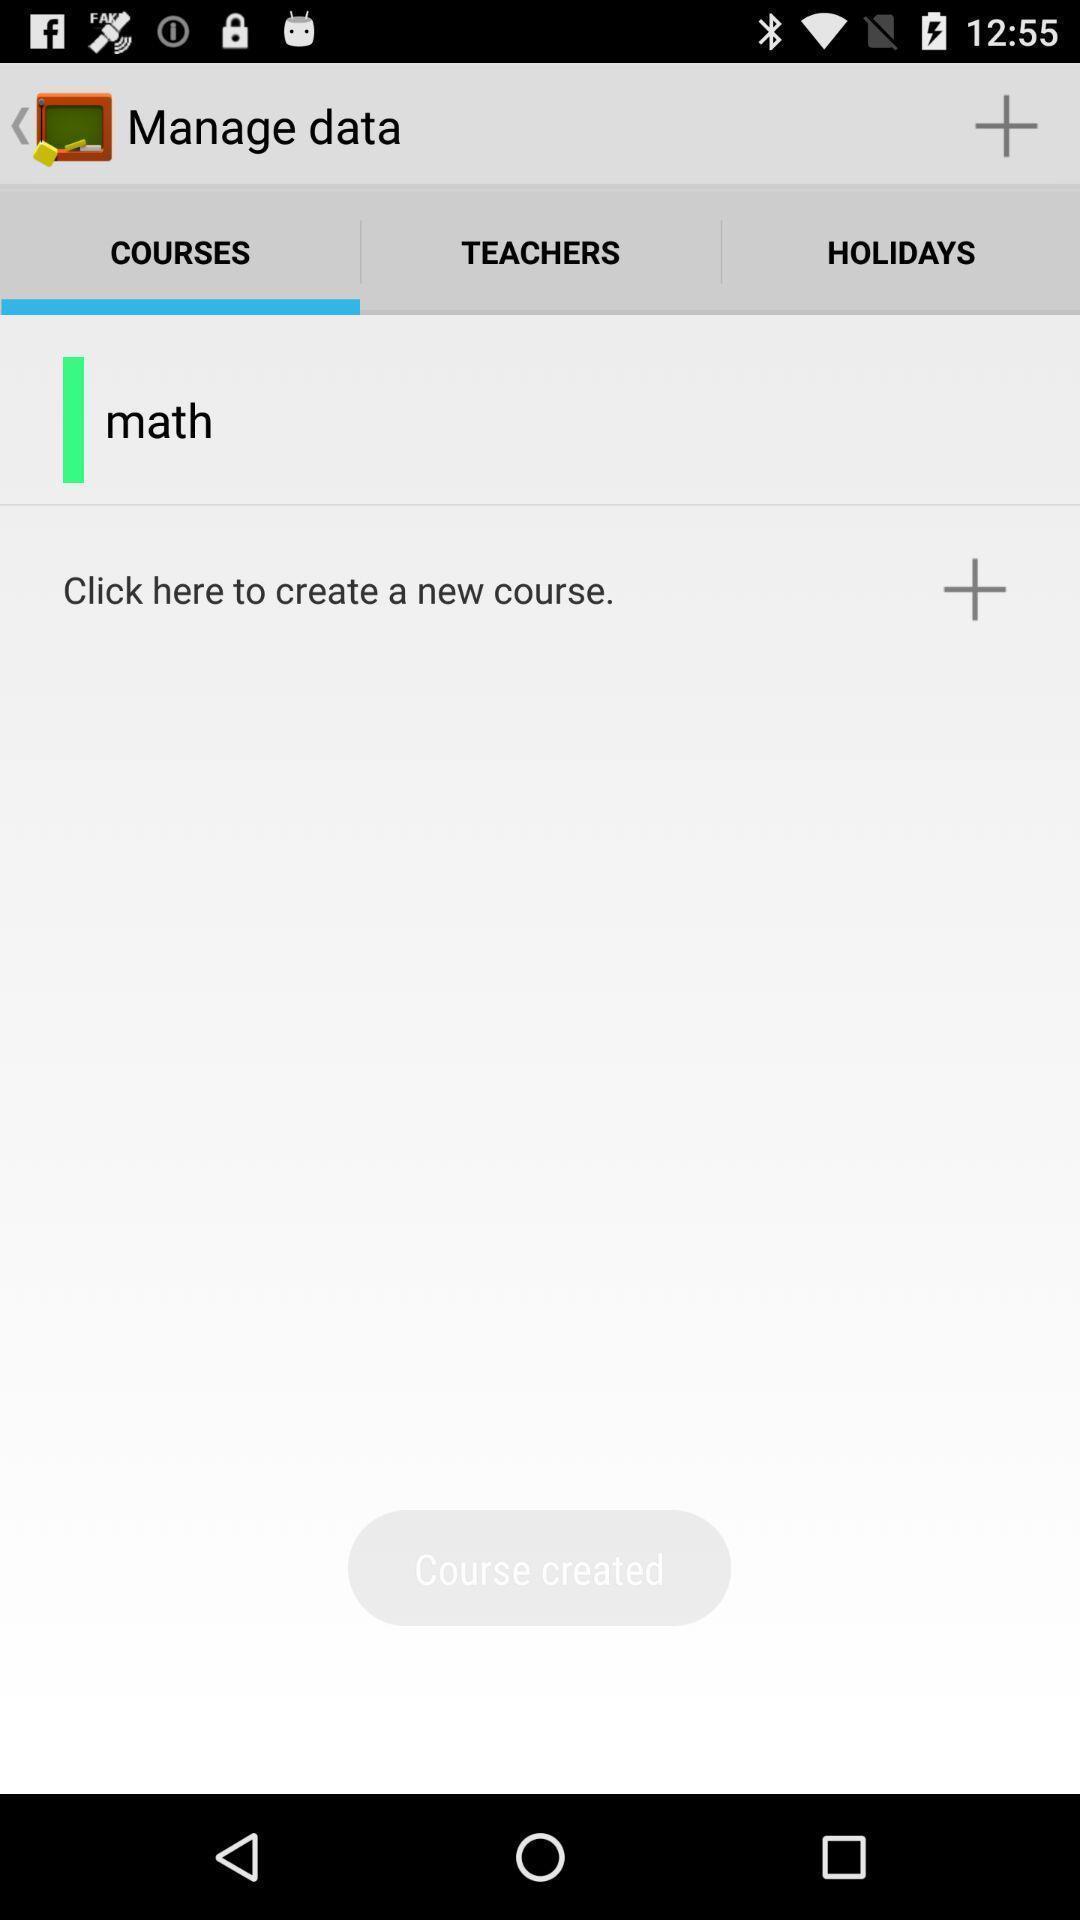Explain what's happening in this screen capture. Screen displaying courses. 